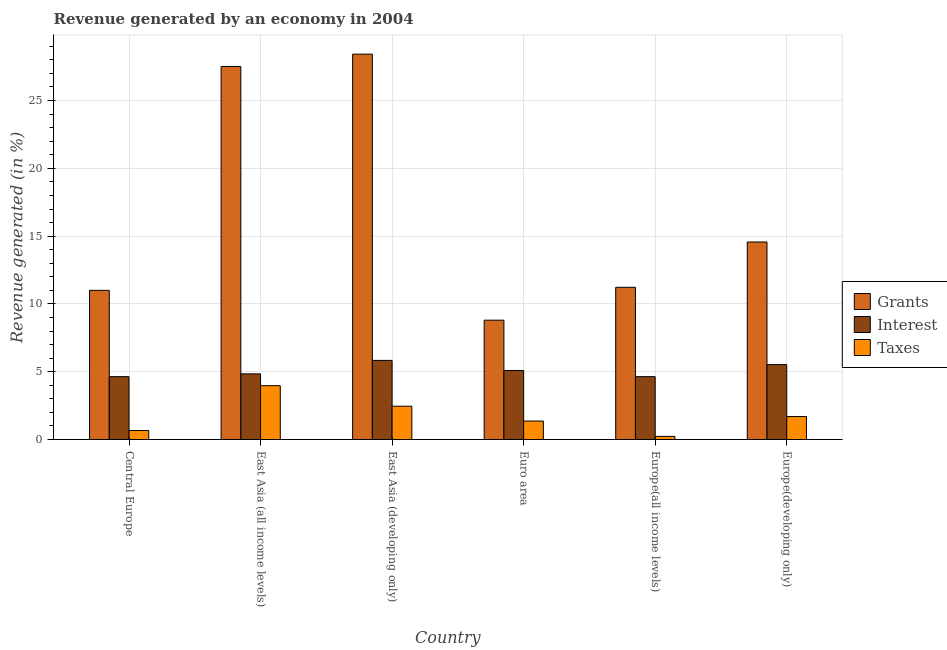How many different coloured bars are there?
Provide a short and direct response. 3. How many groups of bars are there?
Ensure brevity in your answer.  6. Are the number of bars per tick equal to the number of legend labels?
Offer a terse response. Yes. How many bars are there on the 3rd tick from the left?
Your response must be concise. 3. How many bars are there on the 5th tick from the right?
Make the answer very short. 3. What is the label of the 1st group of bars from the left?
Offer a very short reply. Central Europe. In how many cases, is the number of bars for a given country not equal to the number of legend labels?
Your response must be concise. 0. What is the percentage of revenue generated by grants in East Asia (all income levels)?
Offer a very short reply. 27.51. Across all countries, what is the maximum percentage of revenue generated by interest?
Ensure brevity in your answer.  5.84. Across all countries, what is the minimum percentage of revenue generated by grants?
Provide a succinct answer. 8.8. In which country was the percentage of revenue generated by taxes maximum?
Your response must be concise. East Asia (all income levels). In which country was the percentage of revenue generated by taxes minimum?
Your response must be concise. Europe(all income levels). What is the total percentage of revenue generated by grants in the graph?
Make the answer very short. 101.53. What is the difference between the percentage of revenue generated by grants in East Asia (developing only) and that in Europe(developing only)?
Your answer should be very brief. 13.85. What is the difference between the percentage of revenue generated by taxes in Euro area and the percentage of revenue generated by grants in Europe(all income levels)?
Ensure brevity in your answer.  -9.86. What is the average percentage of revenue generated by taxes per country?
Your answer should be compact. 1.73. What is the difference between the percentage of revenue generated by taxes and percentage of revenue generated by grants in East Asia (all income levels)?
Your response must be concise. -23.54. What is the ratio of the percentage of revenue generated by grants in Euro area to that in Europe(developing only)?
Keep it short and to the point. 0.6. Is the percentage of revenue generated by taxes in East Asia (developing only) less than that in Euro area?
Your response must be concise. No. What is the difference between the highest and the second highest percentage of revenue generated by taxes?
Your response must be concise. 1.52. What is the difference between the highest and the lowest percentage of revenue generated by grants?
Offer a very short reply. 19.62. What does the 3rd bar from the left in Central Europe represents?
Your answer should be compact. Taxes. What does the 1st bar from the right in Europe(developing only) represents?
Provide a short and direct response. Taxes. Are all the bars in the graph horizontal?
Your answer should be very brief. No. Are the values on the major ticks of Y-axis written in scientific E-notation?
Give a very brief answer. No. Does the graph contain grids?
Make the answer very short. Yes. How are the legend labels stacked?
Ensure brevity in your answer.  Vertical. What is the title of the graph?
Provide a succinct answer. Revenue generated by an economy in 2004. What is the label or title of the X-axis?
Ensure brevity in your answer.  Country. What is the label or title of the Y-axis?
Offer a very short reply. Revenue generated (in %). What is the Revenue generated (in %) in Grants in Central Europe?
Your answer should be compact. 11. What is the Revenue generated (in %) in Interest in Central Europe?
Offer a very short reply. 4.64. What is the Revenue generated (in %) of Taxes in Central Europe?
Ensure brevity in your answer.  0.66. What is the Revenue generated (in %) of Grants in East Asia (all income levels)?
Your answer should be very brief. 27.51. What is the Revenue generated (in %) in Interest in East Asia (all income levels)?
Offer a very short reply. 4.84. What is the Revenue generated (in %) in Taxes in East Asia (all income levels)?
Give a very brief answer. 3.97. What is the Revenue generated (in %) of Grants in East Asia (developing only)?
Offer a terse response. 28.42. What is the Revenue generated (in %) in Interest in East Asia (developing only)?
Ensure brevity in your answer.  5.84. What is the Revenue generated (in %) in Taxes in East Asia (developing only)?
Keep it short and to the point. 2.46. What is the Revenue generated (in %) of Grants in Euro area?
Offer a terse response. 8.8. What is the Revenue generated (in %) in Interest in Euro area?
Provide a short and direct response. 5.09. What is the Revenue generated (in %) in Taxes in Euro area?
Your response must be concise. 1.36. What is the Revenue generated (in %) of Grants in Europe(all income levels)?
Give a very brief answer. 11.23. What is the Revenue generated (in %) in Interest in Europe(all income levels)?
Offer a terse response. 4.64. What is the Revenue generated (in %) of Taxes in Europe(all income levels)?
Provide a short and direct response. 0.23. What is the Revenue generated (in %) of Grants in Europe(developing only)?
Your response must be concise. 14.57. What is the Revenue generated (in %) of Interest in Europe(developing only)?
Offer a very short reply. 5.53. What is the Revenue generated (in %) in Taxes in Europe(developing only)?
Your answer should be compact. 1.69. Across all countries, what is the maximum Revenue generated (in %) of Grants?
Offer a very short reply. 28.42. Across all countries, what is the maximum Revenue generated (in %) of Interest?
Offer a very short reply. 5.84. Across all countries, what is the maximum Revenue generated (in %) of Taxes?
Ensure brevity in your answer.  3.97. Across all countries, what is the minimum Revenue generated (in %) in Grants?
Provide a short and direct response. 8.8. Across all countries, what is the minimum Revenue generated (in %) of Interest?
Your answer should be very brief. 4.64. Across all countries, what is the minimum Revenue generated (in %) of Taxes?
Keep it short and to the point. 0.23. What is the total Revenue generated (in %) in Grants in the graph?
Offer a very short reply. 101.53. What is the total Revenue generated (in %) in Interest in the graph?
Your answer should be very brief. 30.57. What is the total Revenue generated (in %) in Taxes in the graph?
Offer a terse response. 10.38. What is the difference between the Revenue generated (in %) in Grants in Central Europe and that in East Asia (all income levels)?
Give a very brief answer. -16.51. What is the difference between the Revenue generated (in %) of Interest in Central Europe and that in East Asia (all income levels)?
Provide a succinct answer. -0.21. What is the difference between the Revenue generated (in %) of Taxes in Central Europe and that in East Asia (all income levels)?
Your answer should be very brief. -3.31. What is the difference between the Revenue generated (in %) in Grants in Central Europe and that in East Asia (developing only)?
Offer a very short reply. -17.42. What is the difference between the Revenue generated (in %) of Interest in Central Europe and that in East Asia (developing only)?
Provide a short and direct response. -1.2. What is the difference between the Revenue generated (in %) in Taxes in Central Europe and that in East Asia (developing only)?
Ensure brevity in your answer.  -1.79. What is the difference between the Revenue generated (in %) of Grants in Central Europe and that in Euro area?
Keep it short and to the point. 2.2. What is the difference between the Revenue generated (in %) of Interest in Central Europe and that in Euro area?
Offer a very short reply. -0.46. What is the difference between the Revenue generated (in %) of Taxes in Central Europe and that in Euro area?
Your response must be concise. -0.7. What is the difference between the Revenue generated (in %) of Grants in Central Europe and that in Europe(all income levels)?
Offer a very short reply. -0.22. What is the difference between the Revenue generated (in %) in Interest in Central Europe and that in Europe(all income levels)?
Offer a terse response. 0. What is the difference between the Revenue generated (in %) in Taxes in Central Europe and that in Europe(all income levels)?
Offer a terse response. 0.43. What is the difference between the Revenue generated (in %) of Grants in Central Europe and that in Europe(developing only)?
Provide a short and direct response. -3.57. What is the difference between the Revenue generated (in %) in Interest in Central Europe and that in Europe(developing only)?
Offer a terse response. -0.89. What is the difference between the Revenue generated (in %) of Taxes in Central Europe and that in Europe(developing only)?
Your response must be concise. -1.03. What is the difference between the Revenue generated (in %) in Grants in East Asia (all income levels) and that in East Asia (developing only)?
Give a very brief answer. -0.91. What is the difference between the Revenue generated (in %) of Interest in East Asia (all income levels) and that in East Asia (developing only)?
Provide a succinct answer. -0.99. What is the difference between the Revenue generated (in %) of Taxes in East Asia (all income levels) and that in East Asia (developing only)?
Ensure brevity in your answer.  1.52. What is the difference between the Revenue generated (in %) in Grants in East Asia (all income levels) and that in Euro area?
Offer a very short reply. 18.71. What is the difference between the Revenue generated (in %) of Interest in East Asia (all income levels) and that in Euro area?
Provide a short and direct response. -0.25. What is the difference between the Revenue generated (in %) in Taxes in East Asia (all income levels) and that in Euro area?
Ensure brevity in your answer.  2.61. What is the difference between the Revenue generated (in %) in Grants in East Asia (all income levels) and that in Europe(all income levels)?
Your response must be concise. 16.29. What is the difference between the Revenue generated (in %) of Interest in East Asia (all income levels) and that in Europe(all income levels)?
Keep it short and to the point. 0.21. What is the difference between the Revenue generated (in %) of Taxes in East Asia (all income levels) and that in Europe(all income levels)?
Provide a short and direct response. 3.74. What is the difference between the Revenue generated (in %) in Grants in East Asia (all income levels) and that in Europe(developing only)?
Provide a succinct answer. 12.94. What is the difference between the Revenue generated (in %) of Interest in East Asia (all income levels) and that in Europe(developing only)?
Keep it short and to the point. -0.68. What is the difference between the Revenue generated (in %) of Taxes in East Asia (all income levels) and that in Europe(developing only)?
Keep it short and to the point. 2.28. What is the difference between the Revenue generated (in %) in Grants in East Asia (developing only) and that in Euro area?
Your answer should be very brief. 19.62. What is the difference between the Revenue generated (in %) in Interest in East Asia (developing only) and that in Euro area?
Give a very brief answer. 0.74. What is the difference between the Revenue generated (in %) in Taxes in East Asia (developing only) and that in Euro area?
Keep it short and to the point. 1.09. What is the difference between the Revenue generated (in %) in Grants in East Asia (developing only) and that in Europe(all income levels)?
Your answer should be compact. 17.19. What is the difference between the Revenue generated (in %) of Interest in East Asia (developing only) and that in Europe(all income levels)?
Your response must be concise. 1.2. What is the difference between the Revenue generated (in %) in Taxes in East Asia (developing only) and that in Europe(all income levels)?
Make the answer very short. 2.23. What is the difference between the Revenue generated (in %) of Grants in East Asia (developing only) and that in Europe(developing only)?
Provide a short and direct response. 13.85. What is the difference between the Revenue generated (in %) in Interest in East Asia (developing only) and that in Europe(developing only)?
Provide a short and direct response. 0.31. What is the difference between the Revenue generated (in %) of Taxes in East Asia (developing only) and that in Europe(developing only)?
Your answer should be very brief. 0.76. What is the difference between the Revenue generated (in %) in Grants in Euro area and that in Europe(all income levels)?
Offer a terse response. -2.43. What is the difference between the Revenue generated (in %) in Interest in Euro area and that in Europe(all income levels)?
Offer a terse response. 0.46. What is the difference between the Revenue generated (in %) in Taxes in Euro area and that in Europe(all income levels)?
Ensure brevity in your answer.  1.13. What is the difference between the Revenue generated (in %) in Grants in Euro area and that in Europe(developing only)?
Keep it short and to the point. -5.77. What is the difference between the Revenue generated (in %) in Interest in Euro area and that in Europe(developing only)?
Offer a terse response. -0.43. What is the difference between the Revenue generated (in %) in Taxes in Euro area and that in Europe(developing only)?
Keep it short and to the point. -0.33. What is the difference between the Revenue generated (in %) in Grants in Europe(all income levels) and that in Europe(developing only)?
Your answer should be compact. -3.34. What is the difference between the Revenue generated (in %) in Interest in Europe(all income levels) and that in Europe(developing only)?
Your answer should be compact. -0.89. What is the difference between the Revenue generated (in %) in Taxes in Europe(all income levels) and that in Europe(developing only)?
Your response must be concise. -1.46. What is the difference between the Revenue generated (in %) in Grants in Central Europe and the Revenue generated (in %) in Interest in East Asia (all income levels)?
Provide a short and direct response. 6.16. What is the difference between the Revenue generated (in %) in Grants in Central Europe and the Revenue generated (in %) in Taxes in East Asia (all income levels)?
Provide a short and direct response. 7.03. What is the difference between the Revenue generated (in %) in Interest in Central Europe and the Revenue generated (in %) in Taxes in East Asia (all income levels)?
Your answer should be very brief. 0.67. What is the difference between the Revenue generated (in %) of Grants in Central Europe and the Revenue generated (in %) of Interest in East Asia (developing only)?
Keep it short and to the point. 5.17. What is the difference between the Revenue generated (in %) of Grants in Central Europe and the Revenue generated (in %) of Taxes in East Asia (developing only)?
Keep it short and to the point. 8.55. What is the difference between the Revenue generated (in %) in Interest in Central Europe and the Revenue generated (in %) in Taxes in East Asia (developing only)?
Your answer should be compact. 2.18. What is the difference between the Revenue generated (in %) of Grants in Central Europe and the Revenue generated (in %) of Interest in Euro area?
Give a very brief answer. 5.91. What is the difference between the Revenue generated (in %) in Grants in Central Europe and the Revenue generated (in %) in Taxes in Euro area?
Your response must be concise. 9.64. What is the difference between the Revenue generated (in %) in Interest in Central Europe and the Revenue generated (in %) in Taxes in Euro area?
Ensure brevity in your answer.  3.27. What is the difference between the Revenue generated (in %) of Grants in Central Europe and the Revenue generated (in %) of Interest in Europe(all income levels)?
Your answer should be compact. 6.37. What is the difference between the Revenue generated (in %) of Grants in Central Europe and the Revenue generated (in %) of Taxes in Europe(all income levels)?
Your answer should be very brief. 10.77. What is the difference between the Revenue generated (in %) of Interest in Central Europe and the Revenue generated (in %) of Taxes in Europe(all income levels)?
Your answer should be very brief. 4.41. What is the difference between the Revenue generated (in %) in Grants in Central Europe and the Revenue generated (in %) in Interest in Europe(developing only)?
Ensure brevity in your answer.  5.48. What is the difference between the Revenue generated (in %) of Grants in Central Europe and the Revenue generated (in %) of Taxes in Europe(developing only)?
Give a very brief answer. 9.31. What is the difference between the Revenue generated (in %) in Interest in Central Europe and the Revenue generated (in %) in Taxes in Europe(developing only)?
Your response must be concise. 2.94. What is the difference between the Revenue generated (in %) in Grants in East Asia (all income levels) and the Revenue generated (in %) in Interest in East Asia (developing only)?
Your response must be concise. 21.68. What is the difference between the Revenue generated (in %) in Grants in East Asia (all income levels) and the Revenue generated (in %) in Taxes in East Asia (developing only)?
Your response must be concise. 25.06. What is the difference between the Revenue generated (in %) of Interest in East Asia (all income levels) and the Revenue generated (in %) of Taxes in East Asia (developing only)?
Your answer should be compact. 2.39. What is the difference between the Revenue generated (in %) of Grants in East Asia (all income levels) and the Revenue generated (in %) of Interest in Euro area?
Keep it short and to the point. 22.42. What is the difference between the Revenue generated (in %) of Grants in East Asia (all income levels) and the Revenue generated (in %) of Taxes in Euro area?
Offer a terse response. 26.15. What is the difference between the Revenue generated (in %) in Interest in East Asia (all income levels) and the Revenue generated (in %) in Taxes in Euro area?
Offer a very short reply. 3.48. What is the difference between the Revenue generated (in %) of Grants in East Asia (all income levels) and the Revenue generated (in %) of Interest in Europe(all income levels)?
Offer a terse response. 22.88. What is the difference between the Revenue generated (in %) in Grants in East Asia (all income levels) and the Revenue generated (in %) in Taxes in Europe(all income levels)?
Provide a short and direct response. 27.28. What is the difference between the Revenue generated (in %) of Interest in East Asia (all income levels) and the Revenue generated (in %) of Taxes in Europe(all income levels)?
Provide a short and direct response. 4.61. What is the difference between the Revenue generated (in %) of Grants in East Asia (all income levels) and the Revenue generated (in %) of Interest in Europe(developing only)?
Give a very brief answer. 21.99. What is the difference between the Revenue generated (in %) of Grants in East Asia (all income levels) and the Revenue generated (in %) of Taxes in Europe(developing only)?
Your answer should be very brief. 25.82. What is the difference between the Revenue generated (in %) in Interest in East Asia (all income levels) and the Revenue generated (in %) in Taxes in Europe(developing only)?
Make the answer very short. 3.15. What is the difference between the Revenue generated (in %) of Grants in East Asia (developing only) and the Revenue generated (in %) of Interest in Euro area?
Ensure brevity in your answer.  23.33. What is the difference between the Revenue generated (in %) of Grants in East Asia (developing only) and the Revenue generated (in %) of Taxes in Euro area?
Ensure brevity in your answer.  27.06. What is the difference between the Revenue generated (in %) in Interest in East Asia (developing only) and the Revenue generated (in %) in Taxes in Euro area?
Offer a terse response. 4.47. What is the difference between the Revenue generated (in %) of Grants in East Asia (developing only) and the Revenue generated (in %) of Interest in Europe(all income levels)?
Your answer should be very brief. 23.79. What is the difference between the Revenue generated (in %) of Grants in East Asia (developing only) and the Revenue generated (in %) of Taxes in Europe(all income levels)?
Provide a succinct answer. 28.19. What is the difference between the Revenue generated (in %) of Interest in East Asia (developing only) and the Revenue generated (in %) of Taxes in Europe(all income levels)?
Make the answer very short. 5.6. What is the difference between the Revenue generated (in %) of Grants in East Asia (developing only) and the Revenue generated (in %) of Interest in Europe(developing only)?
Offer a terse response. 22.9. What is the difference between the Revenue generated (in %) of Grants in East Asia (developing only) and the Revenue generated (in %) of Taxes in Europe(developing only)?
Your response must be concise. 26.73. What is the difference between the Revenue generated (in %) in Interest in East Asia (developing only) and the Revenue generated (in %) in Taxes in Europe(developing only)?
Keep it short and to the point. 4.14. What is the difference between the Revenue generated (in %) of Grants in Euro area and the Revenue generated (in %) of Interest in Europe(all income levels)?
Your answer should be very brief. 4.17. What is the difference between the Revenue generated (in %) of Grants in Euro area and the Revenue generated (in %) of Taxes in Europe(all income levels)?
Your answer should be very brief. 8.57. What is the difference between the Revenue generated (in %) of Interest in Euro area and the Revenue generated (in %) of Taxes in Europe(all income levels)?
Your response must be concise. 4.86. What is the difference between the Revenue generated (in %) of Grants in Euro area and the Revenue generated (in %) of Interest in Europe(developing only)?
Offer a very short reply. 3.28. What is the difference between the Revenue generated (in %) of Grants in Euro area and the Revenue generated (in %) of Taxes in Europe(developing only)?
Make the answer very short. 7.11. What is the difference between the Revenue generated (in %) in Interest in Euro area and the Revenue generated (in %) in Taxes in Europe(developing only)?
Provide a short and direct response. 3.4. What is the difference between the Revenue generated (in %) in Grants in Europe(all income levels) and the Revenue generated (in %) in Interest in Europe(developing only)?
Keep it short and to the point. 5.7. What is the difference between the Revenue generated (in %) in Grants in Europe(all income levels) and the Revenue generated (in %) in Taxes in Europe(developing only)?
Ensure brevity in your answer.  9.53. What is the difference between the Revenue generated (in %) in Interest in Europe(all income levels) and the Revenue generated (in %) in Taxes in Europe(developing only)?
Offer a terse response. 2.94. What is the average Revenue generated (in %) in Grants per country?
Your answer should be very brief. 16.92. What is the average Revenue generated (in %) of Interest per country?
Ensure brevity in your answer.  5.09. What is the average Revenue generated (in %) in Taxes per country?
Give a very brief answer. 1.73. What is the difference between the Revenue generated (in %) of Grants and Revenue generated (in %) of Interest in Central Europe?
Your answer should be very brief. 6.37. What is the difference between the Revenue generated (in %) in Grants and Revenue generated (in %) in Taxes in Central Europe?
Your answer should be compact. 10.34. What is the difference between the Revenue generated (in %) of Interest and Revenue generated (in %) of Taxes in Central Europe?
Offer a very short reply. 3.97. What is the difference between the Revenue generated (in %) of Grants and Revenue generated (in %) of Interest in East Asia (all income levels)?
Make the answer very short. 22.67. What is the difference between the Revenue generated (in %) in Grants and Revenue generated (in %) in Taxes in East Asia (all income levels)?
Your answer should be very brief. 23.54. What is the difference between the Revenue generated (in %) of Interest and Revenue generated (in %) of Taxes in East Asia (all income levels)?
Give a very brief answer. 0.87. What is the difference between the Revenue generated (in %) in Grants and Revenue generated (in %) in Interest in East Asia (developing only)?
Ensure brevity in your answer.  22.59. What is the difference between the Revenue generated (in %) in Grants and Revenue generated (in %) in Taxes in East Asia (developing only)?
Your response must be concise. 25.97. What is the difference between the Revenue generated (in %) of Interest and Revenue generated (in %) of Taxes in East Asia (developing only)?
Your answer should be compact. 3.38. What is the difference between the Revenue generated (in %) in Grants and Revenue generated (in %) in Interest in Euro area?
Your answer should be compact. 3.71. What is the difference between the Revenue generated (in %) of Grants and Revenue generated (in %) of Taxes in Euro area?
Give a very brief answer. 7.44. What is the difference between the Revenue generated (in %) of Interest and Revenue generated (in %) of Taxes in Euro area?
Give a very brief answer. 3.73. What is the difference between the Revenue generated (in %) in Grants and Revenue generated (in %) in Interest in Europe(all income levels)?
Your response must be concise. 6.59. What is the difference between the Revenue generated (in %) of Grants and Revenue generated (in %) of Taxes in Europe(all income levels)?
Your response must be concise. 11. What is the difference between the Revenue generated (in %) in Interest and Revenue generated (in %) in Taxes in Europe(all income levels)?
Your answer should be very brief. 4.41. What is the difference between the Revenue generated (in %) of Grants and Revenue generated (in %) of Interest in Europe(developing only)?
Give a very brief answer. 9.04. What is the difference between the Revenue generated (in %) in Grants and Revenue generated (in %) in Taxes in Europe(developing only)?
Provide a short and direct response. 12.87. What is the difference between the Revenue generated (in %) of Interest and Revenue generated (in %) of Taxes in Europe(developing only)?
Your response must be concise. 3.83. What is the ratio of the Revenue generated (in %) of Grants in Central Europe to that in East Asia (all income levels)?
Provide a succinct answer. 0.4. What is the ratio of the Revenue generated (in %) of Interest in Central Europe to that in East Asia (all income levels)?
Your answer should be very brief. 0.96. What is the ratio of the Revenue generated (in %) in Taxes in Central Europe to that in East Asia (all income levels)?
Provide a short and direct response. 0.17. What is the ratio of the Revenue generated (in %) of Grants in Central Europe to that in East Asia (developing only)?
Offer a terse response. 0.39. What is the ratio of the Revenue generated (in %) in Interest in Central Europe to that in East Asia (developing only)?
Your answer should be compact. 0.79. What is the ratio of the Revenue generated (in %) in Taxes in Central Europe to that in East Asia (developing only)?
Provide a succinct answer. 0.27. What is the ratio of the Revenue generated (in %) in Grants in Central Europe to that in Euro area?
Provide a succinct answer. 1.25. What is the ratio of the Revenue generated (in %) in Interest in Central Europe to that in Euro area?
Your answer should be compact. 0.91. What is the ratio of the Revenue generated (in %) of Taxes in Central Europe to that in Euro area?
Give a very brief answer. 0.49. What is the ratio of the Revenue generated (in %) in Grants in Central Europe to that in Europe(all income levels)?
Keep it short and to the point. 0.98. What is the ratio of the Revenue generated (in %) of Interest in Central Europe to that in Europe(all income levels)?
Keep it short and to the point. 1. What is the ratio of the Revenue generated (in %) in Taxes in Central Europe to that in Europe(all income levels)?
Your response must be concise. 2.87. What is the ratio of the Revenue generated (in %) of Grants in Central Europe to that in Europe(developing only)?
Keep it short and to the point. 0.76. What is the ratio of the Revenue generated (in %) in Interest in Central Europe to that in Europe(developing only)?
Offer a terse response. 0.84. What is the ratio of the Revenue generated (in %) in Taxes in Central Europe to that in Europe(developing only)?
Ensure brevity in your answer.  0.39. What is the ratio of the Revenue generated (in %) in Grants in East Asia (all income levels) to that in East Asia (developing only)?
Ensure brevity in your answer.  0.97. What is the ratio of the Revenue generated (in %) of Interest in East Asia (all income levels) to that in East Asia (developing only)?
Your answer should be compact. 0.83. What is the ratio of the Revenue generated (in %) of Taxes in East Asia (all income levels) to that in East Asia (developing only)?
Make the answer very short. 1.62. What is the ratio of the Revenue generated (in %) of Grants in East Asia (all income levels) to that in Euro area?
Provide a short and direct response. 3.13. What is the ratio of the Revenue generated (in %) of Interest in East Asia (all income levels) to that in Euro area?
Offer a very short reply. 0.95. What is the ratio of the Revenue generated (in %) in Taxes in East Asia (all income levels) to that in Euro area?
Ensure brevity in your answer.  2.91. What is the ratio of the Revenue generated (in %) of Grants in East Asia (all income levels) to that in Europe(all income levels)?
Offer a terse response. 2.45. What is the ratio of the Revenue generated (in %) of Interest in East Asia (all income levels) to that in Europe(all income levels)?
Provide a short and direct response. 1.04. What is the ratio of the Revenue generated (in %) in Taxes in East Asia (all income levels) to that in Europe(all income levels)?
Your response must be concise. 17.2. What is the ratio of the Revenue generated (in %) of Grants in East Asia (all income levels) to that in Europe(developing only)?
Make the answer very short. 1.89. What is the ratio of the Revenue generated (in %) in Interest in East Asia (all income levels) to that in Europe(developing only)?
Offer a terse response. 0.88. What is the ratio of the Revenue generated (in %) in Taxes in East Asia (all income levels) to that in Europe(developing only)?
Give a very brief answer. 2.35. What is the ratio of the Revenue generated (in %) in Grants in East Asia (developing only) to that in Euro area?
Your response must be concise. 3.23. What is the ratio of the Revenue generated (in %) of Interest in East Asia (developing only) to that in Euro area?
Ensure brevity in your answer.  1.15. What is the ratio of the Revenue generated (in %) of Taxes in East Asia (developing only) to that in Euro area?
Offer a terse response. 1.8. What is the ratio of the Revenue generated (in %) in Grants in East Asia (developing only) to that in Europe(all income levels)?
Offer a very short reply. 2.53. What is the ratio of the Revenue generated (in %) in Interest in East Asia (developing only) to that in Europe(all income levels)?
Give a very brief answer. 1.26. What is the ratio of the Revenue generated (in %) in Taxes in East Asia (developing only) to that in Europe(all income levels)?
Provide a short and direct response. 10.64. What is the ratio of the Revenue generated (in %) of Grants in East Asia (developing only) to that in Europe(developing only)?
Your answer should be very brief. 1.95. What is the ratio of the Revenue generated (in %) of Interest in East Asia (developing only) to that in Europe(developing only)?
Your answer should be very brief. 1.06. What is the ratio of the Revenue generated (in %) of Taxes in East Asia (developing only) to that in Europe(developing only)?
Give a very brief answer. 1.45. What is the ratio of the Revenue generated (in %) in Grants in Euro area to that in Europe(all income levels)?
Your response must be concise. 0.78. What is the ratio of the Revenue generated (in %) in Interest in Euro area to that in Europe(all income levels)?
Offer a very short reply. 1.1. What is the ratio of the Revenue generated (in %) in Taxes in Euro area to that in Europe(all income levels)?
Make the answer very short. 5.9. What is the ratio of the Revenue generated (in %) of Grants in Euro area to that in Europe(developing only)?
Provide a succinct answer. 0.6. What is the ratio of the Revenue generated (in %) of Interest in Euro area to that in Europe(developing only)?
Offer a terse response. 0.92. What is the ratio of the Revenue generated (in %) in Taxes in Euro area to that in Europe(developing only)?
Your response must be concise. 0.8. What is the ratio of the Revenue generated (in %) of Grants in Europe(all income levels) to that in Europe(developing only)?
Offer a very short reply. 0.77. What is the ratio of the Revenue generated (in %) in Interest in Europe(all income levels) to that in Europe(developing only)?
Your response must be concise. 0.84. What is the ratio of the Revenue generated (in %) of Taxes in Europe(all income levels) to that in Europe(developing only)?
Your answer should be compact. 0.14. What is the difference between the highest and the second highest Revenue generated (in %) in Grants?
Offer a terse response. 0.91. What is the difference between the highest and the second highest Revenue generated (in %) in Interest?
Your response must be concise. 0.31. What is the difference between the highest and the second highest Revenue generated (in %) of Taxes?
Your answer should be very brief. 1.52. What is the difference between the highest and the lowest Revenue generated (in %) in Grants?
Keep it short and to the point. 19.62. What is the difference between the highest and the lowest Revenue generated (in %) in Interest?
Give a very brief answer. 1.2. What is the difference between the highest and the lowest Revenue generated (in %) in Taxes?
Offer a very short reply. 3.74. 